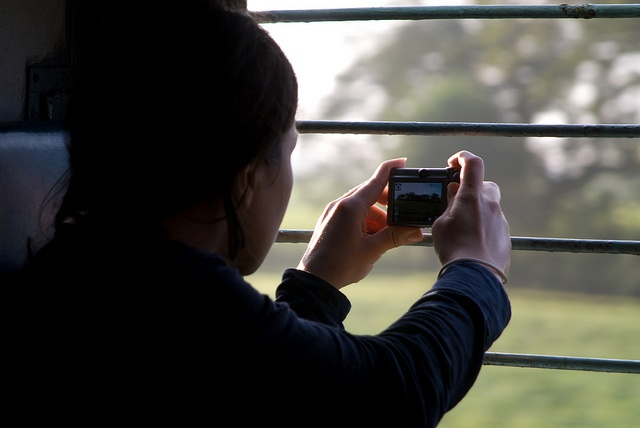Describe the objects in this image and their specific colors. I can see people in black, maroon, gray, and darkgray tones and cell phone in black, navy, gray, and darkblue tones in this image. 